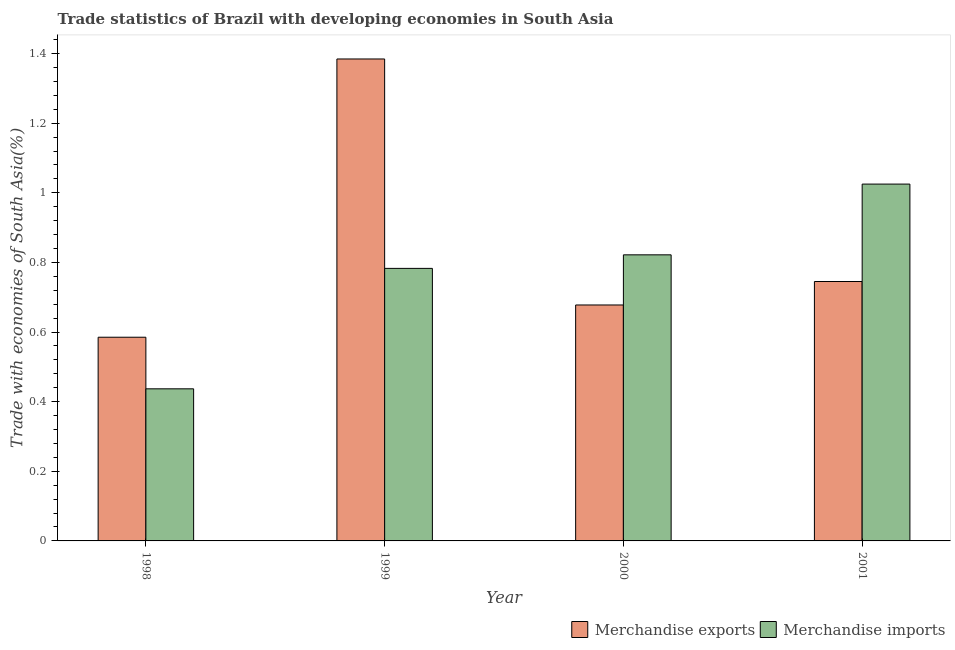How many different coloured bars are there?
Provide a short and direct response. 2. Are the number of bars per tick equal to the number of legend labels?
Provide a succinct answer. Yes. Are the number of bars on each tick of the X-axis equal?
Give a very brief answer. Yes. How many bars are there on the 3rd tick from the left?
Provide a succinct answer. 2. How many bars are there on the 2nd tick from the right?
Offer a very short reply. 2. What is the label of the 2nd group of bars from the left?
Ensure brevity in your answer.  1999. In how many cases, is the number of bars for a given year not equal to the number of legend labels?
Your response must be concise. 0. What is the merchandise imports in 1999?
Offer a very short reply. 0.78. Across all years, what is the maximum merchandise imports?
Your answer should be compact. 1.03. Across all years, what is the minimum merchandise exports?
Your answer should be compact. 0.59. What is the total merchandise imports in the graph?
Your answer should be compact. 3.07. What is the difference between the merchandise exports in 1998 and that in 2001?
Your answer should be very brief. -0.16. What is the difference between the merchandise exports in 2000 and the merchandise imports in 1999?
Ensure brevity in your answer.  -0.71. What is the average merchandise imports per year?
Ensure brevity in your answer.  0.77. In how many years, is the merchandise imports greater than 0.92 %?
Your response must be concise. 1. What is the ratio of the merchandise imports in 2000 to that in 2001?
Provide a short and direct response. 0.8. Is the difference between the merchandise exports in 2000 and 2001 greater than the difference between the merchandise imports in 2000 and 2001?
Offer a terse response. No. What is the difference between the highest and the second highest merchandise imports?
Provide a short and direct response. 0.2. What is the difference between the highest and the lowest merchandise imports?
Make the answer very short. 0.59. Is the sum of the merchandise imports in 1998 and 1999 greater than the maximum merchandise exports across all years?
Keep it short and to the point. Yes. What does the 2nd bar from the right in 2001 represents?
Keep it short and to the point. Merchandise exports. How many bars are there?
Give a very brief answer. 8. Are all the bars in the graph horizontal?
Offer a terse response. No. How many years are there in the graph?
Keep it short and to the point. 4. Where does the legend appear in the graph?
Provide a short and direct response. Bottom right. How many legend labels are there?
Your answer should be very brief. 2. How are the legend labels stacked?
Ensure brevity in your answer.  Horizontal. What is the title of the graph?
Provide a succinct answer. Trade statistics of Brazil with developing economies in South Asia. Does "Education" appear as one of the legend labels in the graph?
Provide a short and direct response. No. What is the label or title of the X-axis?
Your answer should be very brief. Year. What is the label or title of the Y-axis?
Your response must be concise. Trade with economies of South Asia(%). What is the Trade with economies of South Asia(%) of Merchandise exports in 1998?
Your response must be concise. 0.59. What is the Trade with economies of South Asia(%) in Merchandise imports in 1998?
Your answer should be very brief. 0.44. What is the Trade with economies of South Asia(%) in Merchandise exports in 1999?
Keep it short and to the point. 1.38. What is the Trade with economies of South Asia(%) in Merchandise imports in 1999?
Make the answer very short. 0.78. What is the Trade with economies of South Asia(%) in Merchandise exports in 2000?
Offer a terse response. 0.68. What is the Trade with economies of South Asia(%) of Merchandise imports in 2000?
Provide a succinct answer. 0.82. What is the Trade with economies of South Asia(%) in Merchandise exports in 2001?
Make the answer very short. 0.75. What is the Trade with economies of South Asia(%) in Merchandise imports in 2001?
Offer a very short reply. 1.03. Across all years, what is the maximum Trade with economies of South Asia(%) in Merchandise exports?
Provide a succinct answer. 1.38. Across all years, what is the maximum Trade with economies of South Asia(%) in Merchandise imports?
Provide a succinct answer. 1.03. Across all years, what is the minimum Trade with economies of South Asia(%) in Merchandise exports?
Your answer should be compact. 0.59. Across all years, what is the minimum Trade with economies of South Asia(%) of Merchandise imports?
Your answer should be very brief. 0.44. What is the total Trade with economies of South Asia(%) in Merchandise exports in the graph?
Provide a succinct answer. 3.39. What is the total Trade with economies of South Asia(%) in Merchandise imports in the graph?
Your answer should be compact. 3.07. What is the difference between the Trade with economies of South Asia(%) of Merchandise exports in 1998 and that in 1999?
Keep it short and to the point. -0.8. What is the difference between the Trade with economies of South Asia(%) of Merchandise imports in 1998 and that in 1999?
Offer a terse response. -0.35. What is the difference between the Trade with economies of South Asia(%) in Merchandise exports in 1998 and that in 2000?
Offer a very short reply. -0.09. What is the difference between the Trade with economies of South Asia(%) of Merchandise imports in 1998 and that in 2000?
Give a very brief answer. -0.38. What is the difference between the Trade with economies of South Asia(%) of Merchandise exports in 1998 and that in 2001?
Provide a succinct answer. -0.16. What is the difference between the Trade with economies of South Asia(%) of Merchandise imports in 1998 and that in 2001?
Provide a succinct answer. -0.59. What is the difference between the Trade with economies of South Asia(%) in Merchandise exports in 1999 and that in 2000?
Give a very brief answer. 0.71. What is the difference between the Trade with economies of South Asia(%) of Merchandise imports in 1999 and that in 2000?
Keep it short and to the point. -0.04. What is the difference between the Trade with economies of South Asia(%) in Merchandise exports in 1999 and that in 2001?
Ensure brevity in your answer.  0.64. What is the difference between the Trade with economies of South Asia(%) in Merchandise imports in 1999 and that in 2001?
Make the answer very short. -0.24. What is the difference between the Trade with economies of South Asia(%) of Merchandise exports in 2000 and that in 2001?
Provide a short and direct response. -0.07. What is the difference between the Trade with economies of South Asia(%) in Merchandise imports in 2000 and that in 2001?
Make the answer very short. -0.2. What is the difference between the Trade with economies of South Asia(%) in Merchandise exports in 1998 and the Trade with economies of South Asia(%) in Merchandise imports in 1999?
Provide a succinct answer. -0.2. What is the difference between the Trade with economies of South Asia(%) of Merchandise exports in 1998 and the Trade with economies of South Asia(%) of Merchandise imports in 2000?
Your answer should be compact. -0.24. What is the difference between the Trade with economies of South Asia(%) in Merchandise exports in 1998 and the Trade with economies of South Asia(%) in Merchandise imports in 2001?
Offer a very short reply. -0.44. What is the difference between the Trade with economies of South Asia(%) of Merchandise exports in 1999 and the Trade with economies of South Asia(%) of Merchandise imports in 2000?
Your answer should be very brief. 0.56. What is the difference between the Trade with economies of South Asia(%) of Merchandise exports in 1999 and the Trade with economies of South Asia(%) of Merchandise imports in 2001?
Your answer should be compact. 0.36. What is the difference between the Trade with economies of South Asia(%) in Merchandise exports in 2000 and the Trade with economies of South Asia(%) in Merchandise imports in 2001?
Provide a short and direct response. -0.35. What is the average Trade with economies of South Asia(%) in Merchandise exports per year?
Provide a succinct answer. 0.85. What is the average Trade with economies of South Asia(%) of Merchandise imports per year?
Keep it short and to the point. 0.77. In the year 1998, what is the difference between the Trade with economies of South Asia(%) of Merchandise exports and Trade with economies of South Asia(%) of Merchandise imports?
Offer a very short reply. 0.15. In the year 1999, what is the difference between the Trade with economies of South Asia(%) in Merchandise exports and Trade with economies of South Asia(%) in Merchandise imports?
Provide a succinct answer. 0.6. In the year 2000, what is the difference between the Trade with economies of South Asia(%) of Merchandise exports and Trade with economies of South Asia(%) of Merchandise imports?
Keep it short and to the point. -0.14. In the year 2001, what is the difference between the Trade with economies of South Asia(%) of Merchandise exports and Trade with economies of South Asia(%) of Merchandise imports?
Provide a succinct answer. -0.28. What is the ratio of the Trade with economies of South Asia(%) of Merchandise exports in 1998 to that in 1999?
Offer a very short reply. 0.42. What is the ratio of the Trade with economies of South Asia(%) of Merchandise imports in 1998 to that in 1999?
Make the answer very short. 0.56. What is the ratio of the Trade with economies of South Asia(%) of Merchandise exports in 1998 to that in 2000?
Your answer should be compact. 0.86. What is the ratio of the Trade with economies of South Asia(%) in Merchandise imports in 1998 to that in 2000?
Ensure brevity in your answer.  0.53. What is the ratio of the Trade with economies of South Asia(%) of Merchandise exports in 1998 to that in 2001?
Your response must be concise. 0.79. What is the ratio of the Trade with economies of South Asia(%) in Merchandise imports in 1998 to that in 2001?
Your answer should be compact. 0.43. What is the ratio of the Trade with economies of South Asia(%) of Merchandise exports in 1999 to that in 2000?
Offer a very short reply. 2.04. What is the ratio of the Trade with economies of South Asia(%) of Merchandise imports in 1999 to that in 2000?
Ensure brevity in your answer.  0.95. What is the ratio of the Trade with economies of South Asia(%) in Merchandise exports in 1999 to that in 2001?
Your answer should be very brief. 1.86. What is the ratio of the Trade with economies of South Asia(%) of Merchandise imports in 1999 to that in 2001?
Your response must be concise. 0.76. What is the ratio of the Trade with economies of South Asia(%) of Merchandise exports in 2000 to that in 2001?
Provide a succinct answer. 0.91. What is the ratio of the Trade with economies of South Asia(%) in Merchandise imports in 2000 to that in 2001?
Your answer should be very brief. 0.8. What is the difference between the highest and the second highest Trade with economies of South Asia(%) in Merchandise exports?
Offer a very short reply. 0.64. What is the difference between the highest and the second highest Trade with economies of South Asia(%) in Merchandise imports?
Make the answer very short. 0.2. What is the difference between the highest and the lowest Trade with economies of South Asia(%) in Merchandise exports?
Your response must be concise. 0.8. What is the difference between the highest and the lowest Trade with economies of South Asia(%) in Merchandise imports?
Your response must be concise. 0.59. 